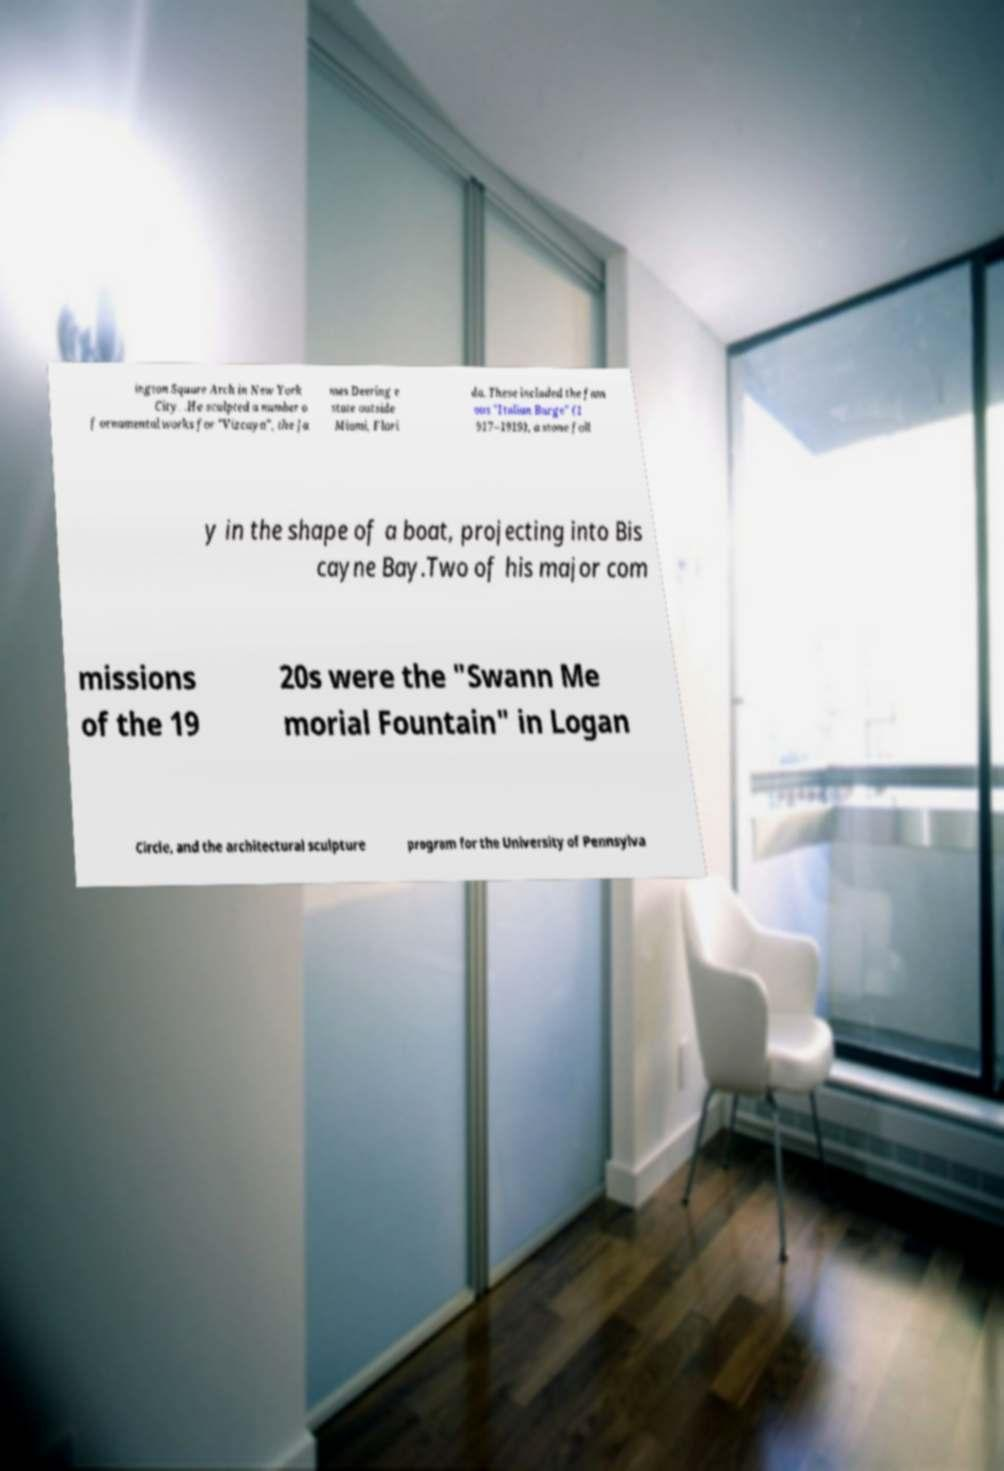Could you assist in decoding the text presented in this image and type it out clearly? ington Square Arch in New York City. .He sculpted a number o f ornamental works for "Vizcaya", the Ja mes Deering e state outside Miami, Flori da. These included the fam ous "Italian Barge" (1 917–1919), a stone foll y in the shape of a boat, projecting into Bis cayne Bay.Two of his major com missions of the 19 20s were the "Swann Me morial Fountain" in Logan Circle, and the architectural sculpture program for the University of Pennsylva 